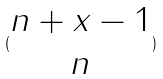Convert formula to latex. <formula><loc_0><loc_0><loc_500><loc_500>( \begin{matrix} n + x - 1 \\ n \end{matrix} )</formula> 